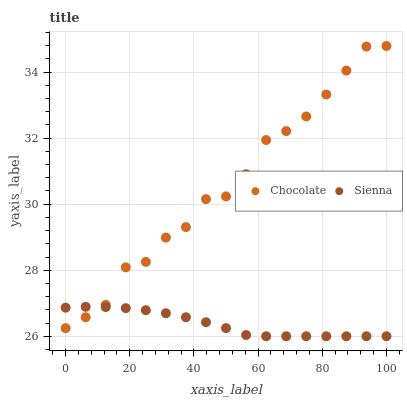Does Sienna have the minimum area under the curve?
Answer yes or no. Yes. Does Chocolate have the maximum area under the curve?
Answer yes or no. Yes. Does Chocolate have the minimum area under the curve?
Answer yes or no. No. Is Sienna the smoothest?
Answer yes or no. Yes. Is Chocolate the roughest?
Answer yes or no. Yes. Is Chocolate the smoothest?
Answer yes or no. No. Does Sienna have the lowest value?
Answer yes or no. Yes. Does Chocolate have the lowest value?
Answer yes or no. No. Does Chocolate have the highest value?
Answer yes or no. Yes. Does Sienna intersect Chocolate?
Answer yes or no. Yes. Is Sienna less than Chocolate?
Answer yes or no. No. Is Sienna greater than Chocolate?
Answer yes or no. No. 